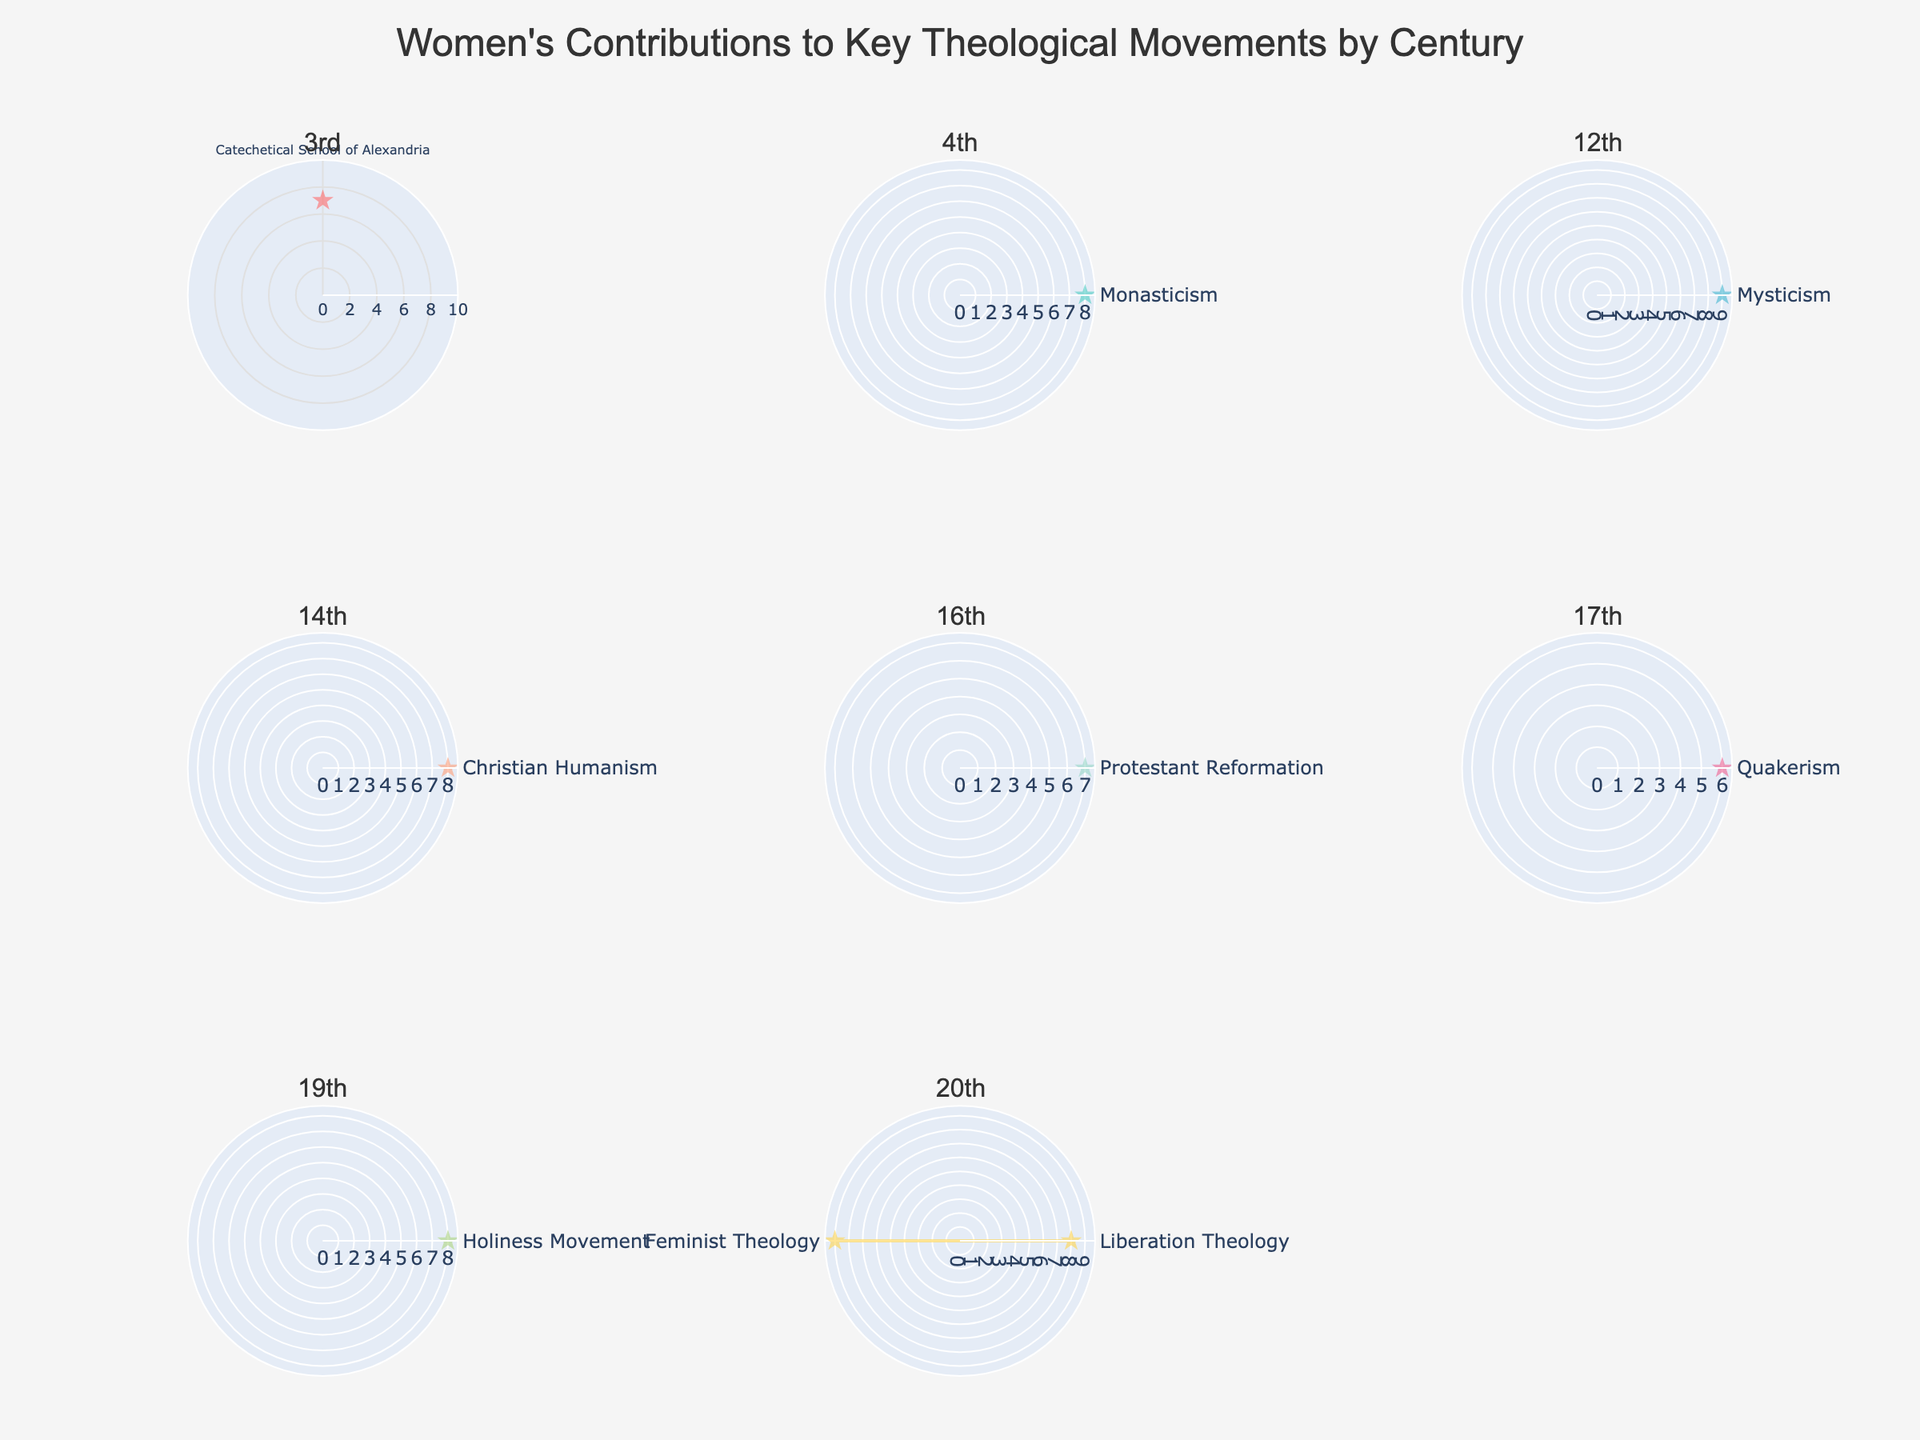What is the title of the figure? The title of any figure is usually displayed at the top center. In this case, the title is "Women's Contributions to Key Theological Movements by Century."
Answer: Women's Contributions to Key Theological Movements by Century Which century has the highest Impact Rating in its subplot? You can compare the maximum Impact Ratings from each subplot. The 12th-century subplot has Hildegard of Bingen with a rating of 9, which is the highest among all subplots.
Answer: 12th How many data points are there in the 4th-century subplot? By looking at the subplot for the 4th century, we can count the number of theta labels or markers. The 4th century has one data point titled "Monasticism" linked to Macrina the Younger.
Answer: 1 Which theological movement had a contributor with an Impact Rating of 8 in the 20th century? In the 20th-century subplot, identify the movements where the radius value is 8. The movements are "Liberation Theology" and "Feminist Theology."
Answer: Liberation Theology, Feminist Theology What is the average Impact Rating for the contributors in the 20th century? The contributors in the 20th century are Ivone Gebara (rating 8) and Rosemary Radford Ruether (rating 9). Average Impact Rating is calculated as (8+9)/2 = 8.5.
Answer: 8.5 Which theological movement in the 16th century is represented, and what is the Impact Rating of its contributor? Look at the 16th-century subplot. It represents the "Protestant Reformation" and has an Impact Rating of 7.
Answer: Protestant Reformation, 7 Compare the Impact Ratings of contributors in the 19th century and the 3rd century. Which one is higher? Identify the individual ratings from both centuries. The 19th-century subplot with Phoebe Palmer has a rating of 8, while the 3rd-century subplot with Origen's Female Students has a rating of 7. 8 is higher than 7.
Answer: 19th century What color is used to represent the 17th century subplot? The color palette provided assigns specific colors to the subplots. The 17th century subplot uses a color in the order, which appears to be '#45B7D1,' represented as a shade of blue.
Answer: Blue (shade) 